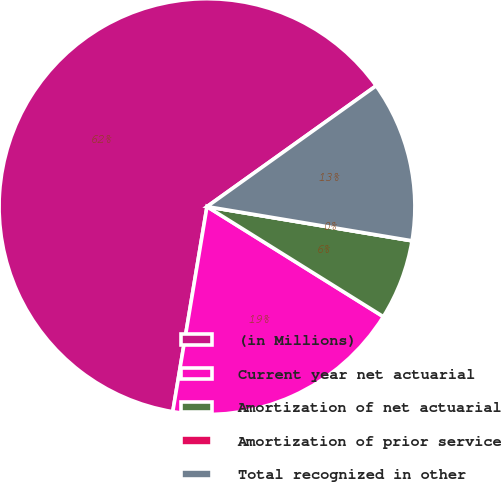<chart> <loc_0><loc_0><loc_500><loc_500><pie_chart><fcel>(in Millions)<fcel>Current year net actuarial<fcel>Amortization of net actuarial<fcel>Amortization of prior service<fcel>Total recognized in other<nl><fcel>62.49%<fcel>18.75%<fcel>6.25%<fcel>0.0%<fcel>12.5%<nl></chart> 